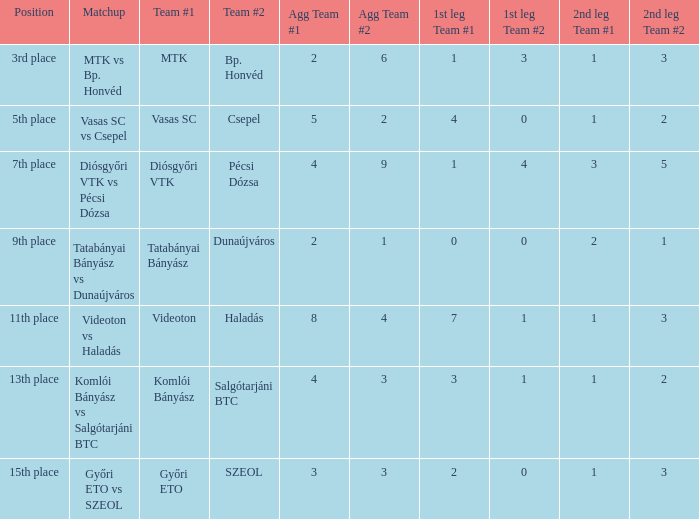What is the 2nd leg of the 4-9 agg.? 3-5. 